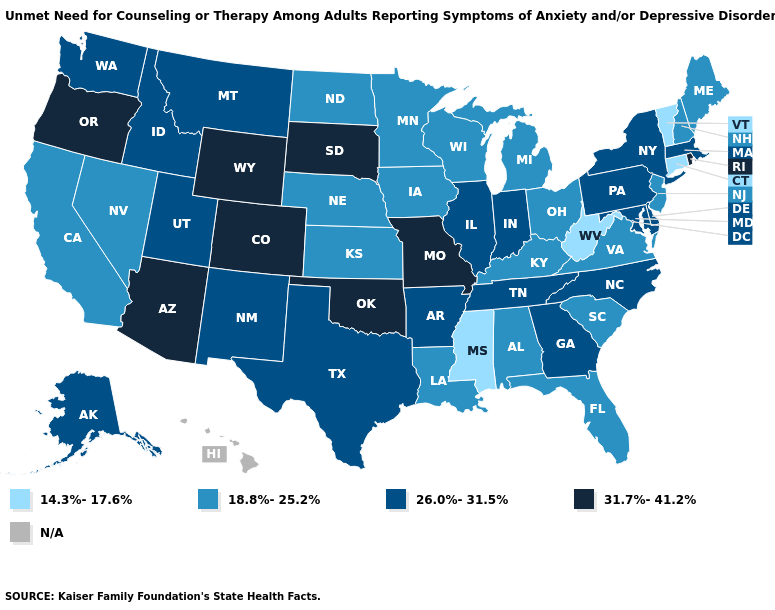What is the value of Nevada?
Quick response, please. 18.8%-25.2%. Which states hav the highest value in the Northeast?
Quick response, please. Rhode Island. Which states have the lowest value in the South?
Concise answer only. Mississippi, West Virginia. What is the highest value in the MidWest ?
Be succinct. 31.7%-41.2%. What is the value of Vermont?
Give a very brief answer. 14.3%-17.6%. Is the legend a continuous bar?
Short answer required. No. What is the lowest value in states that border South Carolina?
Write a very short answer. 26.0%-31.5%. What is the highest value in states that border Arkansas?
Be succinct. 31.7%-41.2%. What is the lowest value in the West?
Be succinct. 18.8%-25.2%. What is the value of Vermont?
Be succinct. 14.3%-17.6%. What is the value of New Mexico?
Write a very short answer. 26.0%-31.5%. What is the value of Illinois?
Write a very short answer. 26.0%-31.5%. 